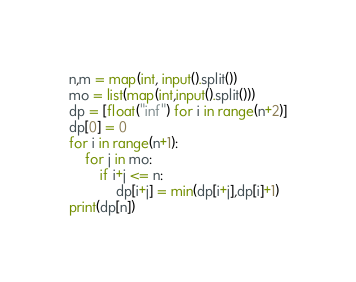Convert code to text. <code><loc_0><loc_0><loc_500><loc_500><_Python_>n,m = map(int, input().split())
mo = list(map(int,input().split()))
dp = [float("inf") for i in range(n+2)]
dp[0] = 0
for i in range(n+1):
    for j in mo:
        if i+j <= n:
            dp[i+j] = min(dp[i+j],dp[i]+1)
print(dp[n])
</code> 